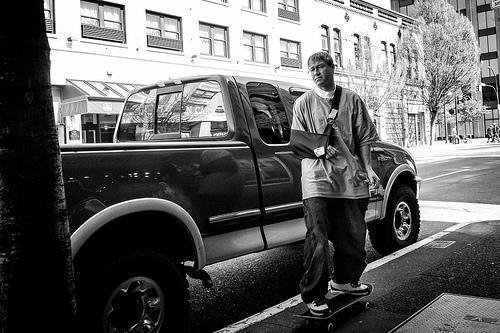How many people are on the skateboard?
Give a very brief answer. 1. How many vehicles are there?
Give a very brief answer. 1. How many people are riding pike near the car?
Give a very brief answer. 0. 